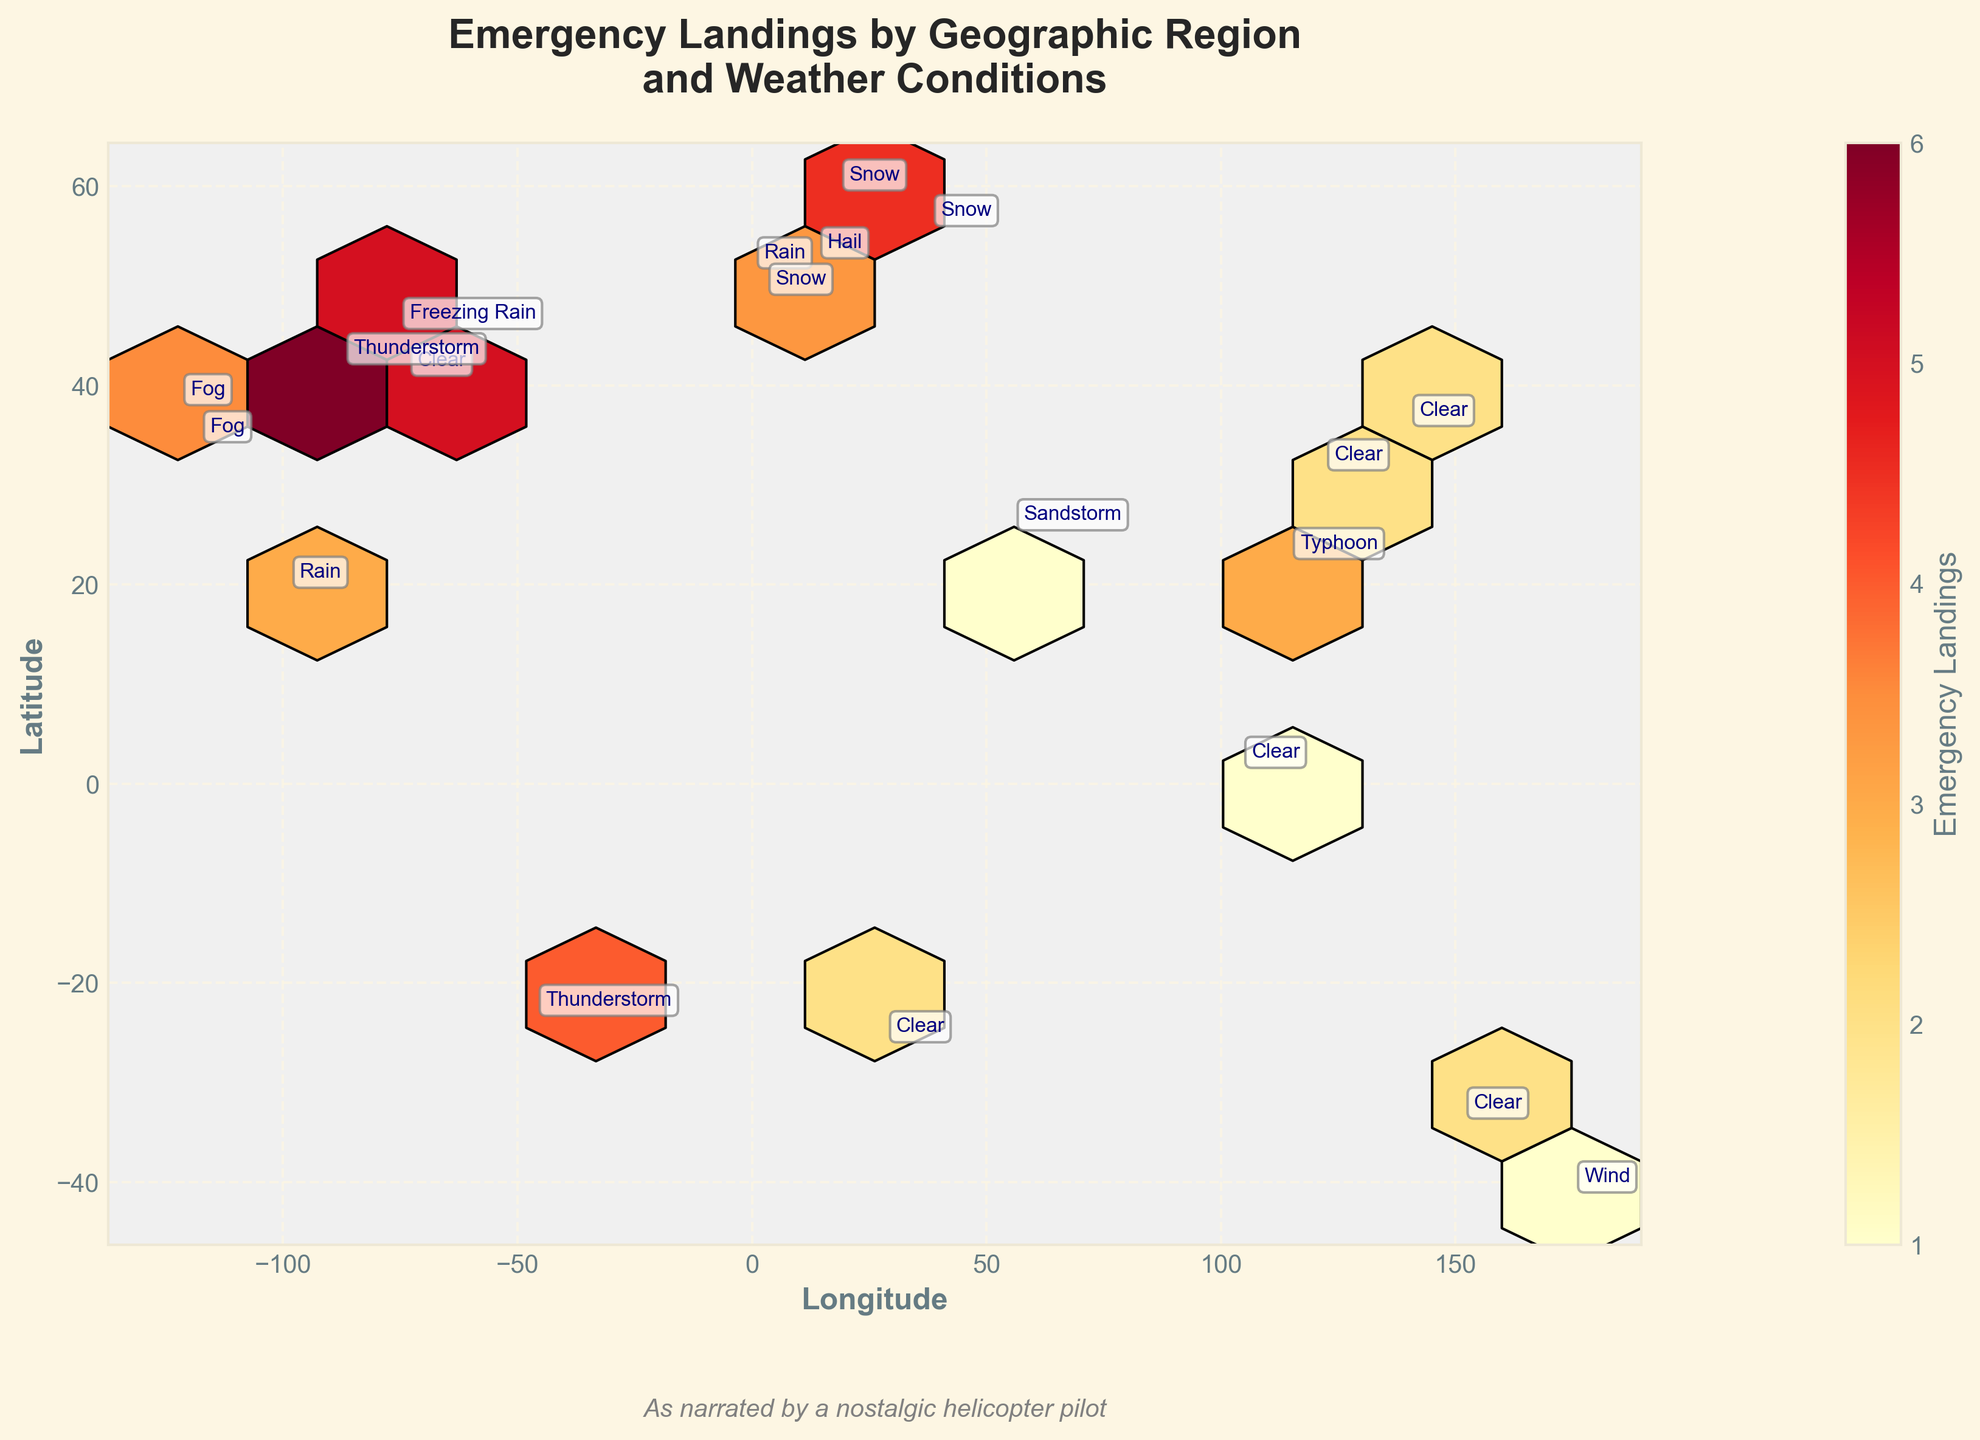How many geographic regions experienced emergency landings? Count the number of unique locations marked by their latitude and longitude on the plot.
Answer: 19 Which weather condition is annotated at the geographic region with the highest number of emergency landings? Identify the location with the darkest hexagon representing the maximum emergency landings and note its weather condition annotation.
Answer: Thunderstorm What is the range of emergency landings depicted by the color bar? Refer to the color bar on the right side of the plot. It shows the range of emergency landings with its graduated colors.
Answer: 1-6 Which geographic region experienced emergency landings due to a typhoon? Look for the annotation "Typhoon" on the plot and identify its corresponding longitude and latitude coordinates.
Answer: 22.3193, 114.1694 (Hong Kong) Out of the locations with thunderstorms, which one had a higher number of emergency landings? Compare the emergency landings for locations with thunderstorms by looking at the color intensity of hexagons at their coordinates.
Answer: 41.8781, -87.6298 (Chicago) Which two geographic regions with fog as weather condition experienced emergency landings, and how many emergency landings did each have? Find the annotated "Fog" weather conditions and identify the corresponding emergency landings at those coordinates.
Answer: Los Angeles (3), San Francisco (4) Is there any location with snow that had emergency landings, and if so, how many regions had this condition? Look for the "Snow" annotations on the plot and count the distinct geographic regions.
Answer: Three regions (Paris, Moscow, Stockholm) What is the average number of emergency landings for geographic regions annotated with "Clear" weather condition? Sum the emergency landings for regions with "Clear" annotation and divide by the number of such regions.
Answer: (5+2+2+2+1)/5 = 2.4 Which region has a single emergency landing event, and what weather condition is associated with it? Identify the hexagon with the lightest shade, annotated by a weather condition, at its respective coordinates.
Answer: Dubai (Sandstorm) What pattern can be observed between weather conditions and the frequency of emergency landings? Analyze the annotations and the color intensity of hexagons to identify any observable relationship between weather conditions and emergency landing frequencies.
Answer: Variable, but higher frequencies seem to be associated with adverse weather conditions like thunderstorms, snow, or fog 